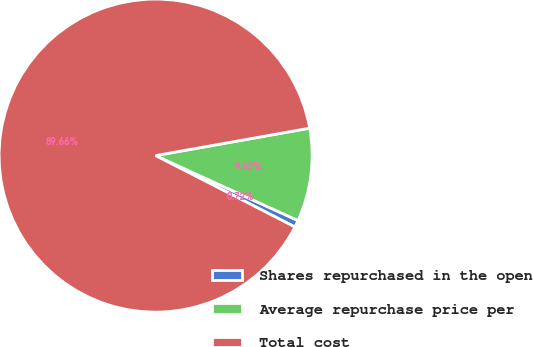Convert chart to OTSL. <chart><loc_0><loc_0><loc_500><loc_500><pie_chart><fcel>Shares repurchased in the open<fcel>Average repurchase price per<fcel>Total cost<nl><fcel>0.72%<fcel>9.62%<fcel>89.66%<nl></chart> 